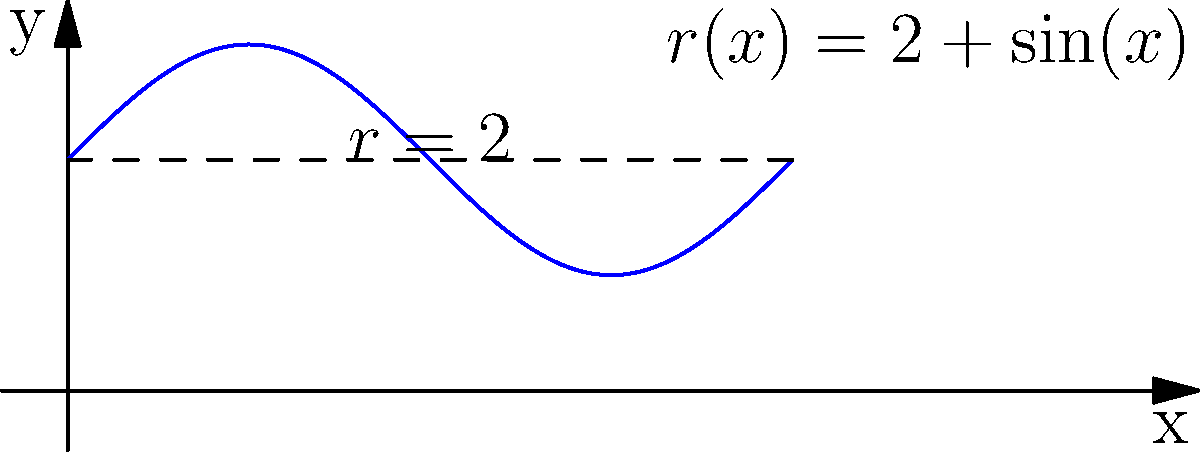A pipe has a varying radius given by the function $r(x) = 2 + \sin(x)$ cm, where $x$ is the distance along the pipe in meters. If fluid flows through the pipe at a constant rate of 10 L/s, determine the maximum velocity of the fluid in the pipe. To solve this problem, we'll follow these steps:

1) The flow rate $Q$ is constant throughout the pipe and is given as 10 L/s. We need to convert this to $\text{cm}^3/\text{s}$:

   $Q = 10 \text{ L/s} = 10,000 \text{ cm}^3/\text{s}$

2) The cross-sectional area of the pipe at any point $x$ is:

   $A(x) = \pi r(x)^2 = \pi (2 + \sin(x))^2 \text{ cm}^2$

3) The velocity $v(x)$ at any point is given by:

   $v(x) = \frac{Q}{A(x)} = \frac{10,000}{\pi (2 + \sin(x))^2} \text{ cm/s}$

4) To find the maximum velocity, we need to find where $A(x)$ is minimum, which occurs when $r(x)$ is minimum.

5) The minimum value of $r(x)$ occurs when $\sin(x) = -1$, giving:

   $r_{min} = 2 - 1 = 1 \text{ cm}$

6) Therefore, the maximum velocity is:

   $v_{max} = \frac{10,000}{\pi (1)^2} = \frac{10,000}{\pi} \text{ cm/s}$

7) Simplifying:

   $v_{max} \approx 3183.10 \text{ cm/s} = 31.83 \text{ m/s}$
Answer: 31.83 m/s 